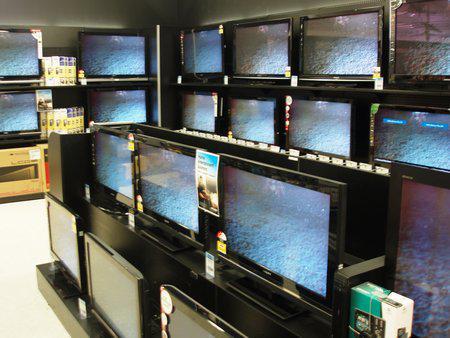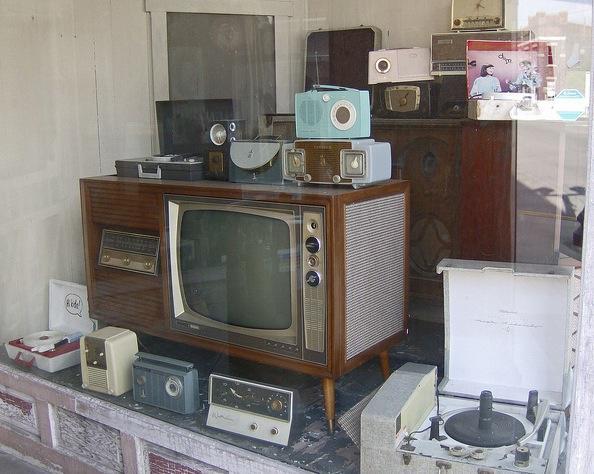The first image is the image on the left, the second image is the image on the right. Given the left and right images, does the statement "A single console television sits in the image on the right." hold true? Answer yes or no. Yes. The first image is the image on the left, the second image is the image on the right. For the images shown, is this caption "At least one television is on." true? Answer yes or no. Yes. 